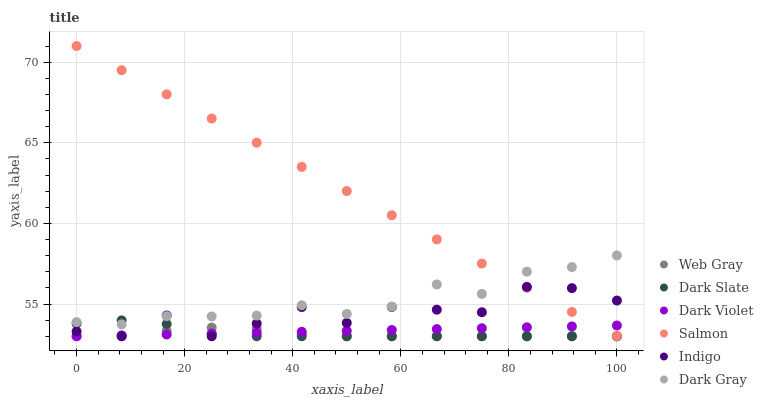Does Web Gray have the minimum area under the curve?
Answer yes or no. Yes. Does Salmon have the maximum area under the curve?
Answer yes or no. Yes. Does Indigo have the minimum area under the curve?
Answer yes or no. No. Does Indigo have the maximum area under the curve?
Answer yes or no. No. Is Dark Violet the smoothest?
Answer yes or no. Yes. Is Indigo the roughest?
Answer yes or no. Yes. Is Salmon the smoothest?
Answer yes or no. No. Is Salmon the roughest?
Answer yes or no. No. Does Web Gray have the lowest value?
Answer yes or no. Yes. Does Salmon have the lowest value?
Answer yes or no. No. Does Salmon have the highest value?
Answer yes or no. Yes. Does Indigo have the highest value?
Answer yes or no. No. Is Web Gray less than Salmon?
Answer yes or no. Yes. Is Salmon greater than Web Gray?
Answer yes or no. Yes. Does Dark Violet intersect Indigo?
Answer yes or no. Yes. Is Dark Violet less than Indigo?
Answer yes or no. No. Is Dark Violet greater than Indigo?
Answer yes or no. No. Does Web Gray intersect Salmon?
Answer yes or no. No. 